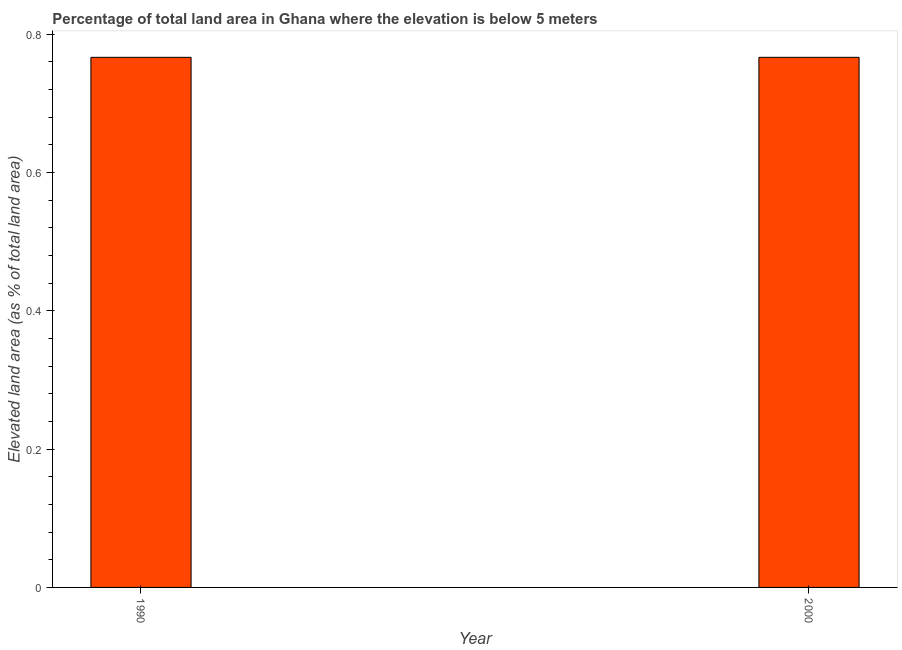Does the graph contain any zero values?
Offer a terse response. No. Does the graph contain grids?
Give a very brief answer. No. What is the title of the graph?
Offer a terse response. Percentage of total land area in Ghana where the elevation is below 5 meters. What is the label or title of the X-axis?
Your answer should be very brief. Year. What is the label or title of the Y-axis?
Offer a terse response. Elevated land area (as % of total land area). What is the total elevated land area in 1990?
Your response must be concise. 0.77. Across all years, what is the maximum total elevated land area?
Make the answer very short. 0.77. Across all years, what is the minimum total elevated land area?
Offer a terse response. 0.77. In which year was the total elevated land area maximum?
Your answer should be compact. 1990. In which year was the total elevated land area minimum?
Offer a terse response. 1990. What is the sum of the total elevated land area?
Your response must be concise. 1.53. What is the difference between the total elevated land area in 1990 and 2000?
Offer a terse response. 0. What is the average total elevated land area per year?
Make the answer very short. 0.77. What is the median total elevated land area?
Offer a terse response. 0.77. In how many years, is the total elevated land area greater than the average total elevated land area taken over all years?
Your answer should be very brief. 0. How many bars are there?
Provide a short and direct response. 2. Are all the bars in the graph horizontal?
Give a very brief answer. No. What is the difference between two consecutive major ticks on the Y-axis?
Provide a short and direct response. 0.2. What is the Elevated land area (as % of total land area) of 1990?
Keep it short and to the point. 0.77. What is the Elevated land area (as % of total land area) in 2000?
Ensure brevity in your answer.  0.77. What is the ratio of the Elevated land area (as % of total land area) in 1990 to that in 2000?
Provide a short and direct response. 1. 